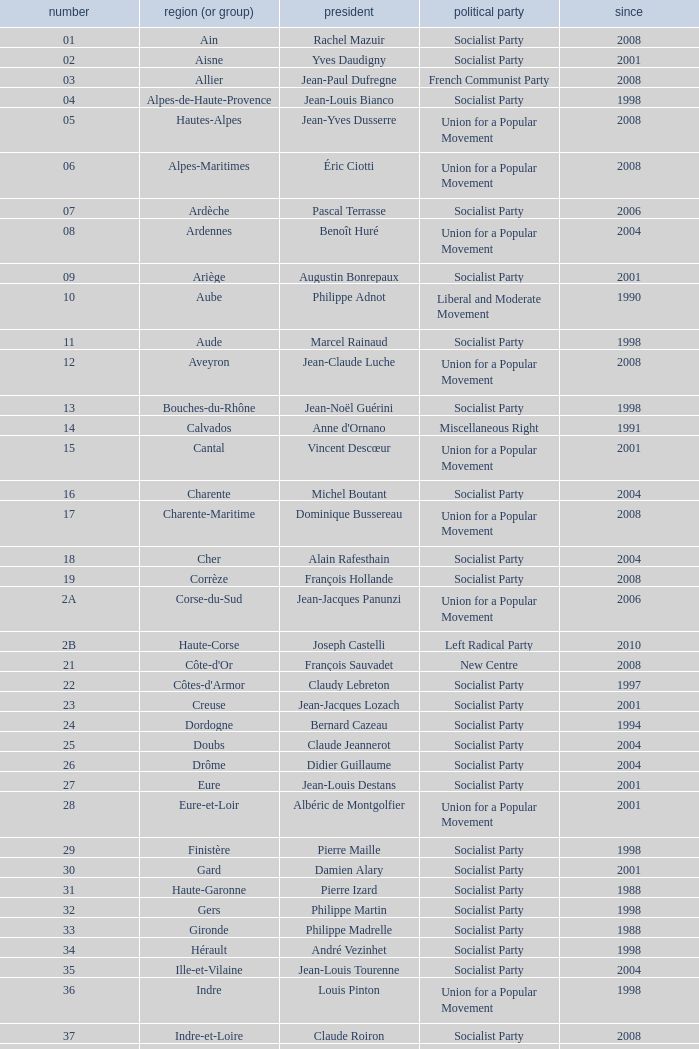What number corresponds to Presidet Yves Krattinger of the Socialist party? 70.0. 